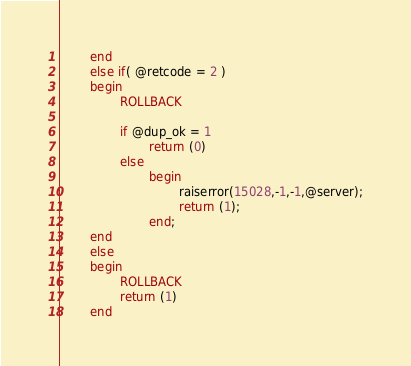<code> <loc_0><loc_0><loc_500><loc_500><_SQL_>        end
        else if( @retcode = 2 )
        begin
                ROLLBACK

                if @dup_ok = 1
                        return (0)
                else
                        begin
                                raiserror(15028,-1,-1,@server);
                                return (1);
                        end;
        end
        else 
        begin
                ROLLBACK
                return (1)
        end
</code> 